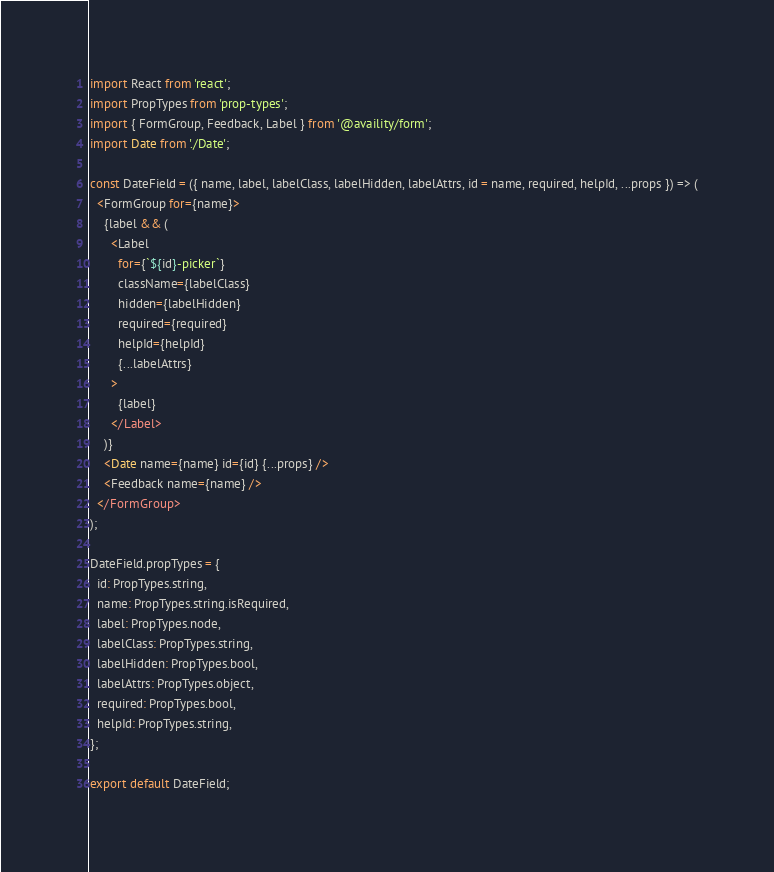Convert code to text. <code><loc_0><loc_0><loc_500><loc_500><_JavaScript_>import React from 'react';
import PropTypes from 'prop-types';
import { FormGroup, Feedback, Label } from '@availity/form';
import Date from './Date';

const DateField = ({ name, label, labelClass, labelHidden, labelAttrs, id = name, required, helpId, ...props }) => (
  <FormGroup for={name}>
    {label && (
      <Label
        for={`${id}-picker`}
        className={labelClass}
        hidden={labelHidden}
        required={required}
        helpId={helpId}
        {...labelAttrs}
      >
        {label}
      </Label>
    )}
    <Date name={name} id={id} {...props} />
    <Feedback name={name} />
  </FormGroup>
);

DateField.propTypes = {
  id: PropTypes.string,
  name: PropTypes.string.isRequired,
  label: PropTypes.node,
  labelClass: PropTypes.string,
  labelHidden: PropTypes.bool,
  labelAttrs: PropTypes.object,
  required: PropTypes.bool,
  helpId: PropTypes.string,
};

export default DateField;
</code> 